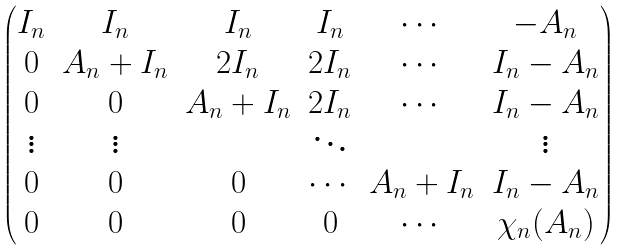Convert formula to latex. <formula><loc_0><loc_0><loc_500><loc_500>\begin{pmatrix} I _ { n } & I _ { n } & I _ { n } & I _ { n } & \cdots & - A _ { n } \\ 0 & A _ { n } + I _ { n } & 2 I _ { n } & 2 I _ { n } & \cdots & I _ { n } - A _ { n } \\ 0 & 0 & A _ { n } + I _ { n } & 2 I _ { n } & \cdots & I _ { n } - A _ { n } \\ \vdots & \vdots & & \ddots & & \vdots \\ 0 & 0 & 0 & \cdots & A _ { n } + I _ { n } & I _ { n } - A _ { n } \\ 0 & 0 & 0 & 0 & \cdots & \chi _ { n } ( A _ { n } ) \end{pmatrix}</formula> 